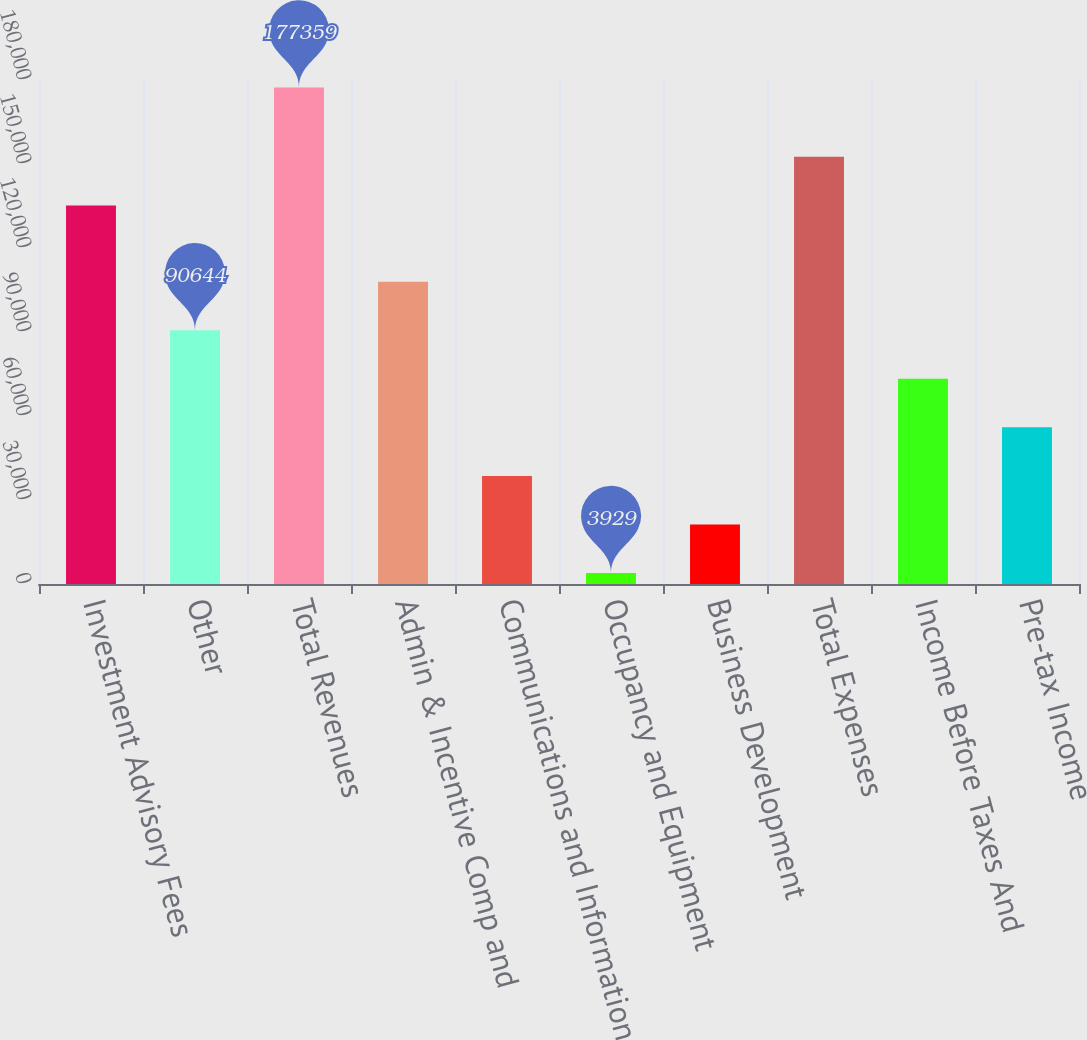<chart> <loc_0><loc_0><loc_500><loc_500><bar_chart><fcel>Investment Advisory Fees<fcel>Other<fcel>Total Revenues<fcel>Admin & Incentive Comp and<fcel>Communications and Information<fcel>Occupancy and Equipment<fcel>Business Development<fcel>Total Expenses<fcel>Income Before Taxes And<fcel>Pre-tax Income<nl><fcel>135223<fcel>90644<fcel>177359<fcel>107987<fcel>38615<fcel>3929<fcel>21272<fcel>152566<fcel>73301<fcel>55958<nl></chart> 